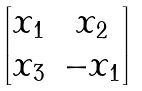<formula> <loc_0><loc_0><loc_500><loc_500>\begin{bmatrix} x _ { 1 } & x _ { 2 } \\ x _ { 3 } & - x _ { 1 } \end{bmatrix}</formula> 